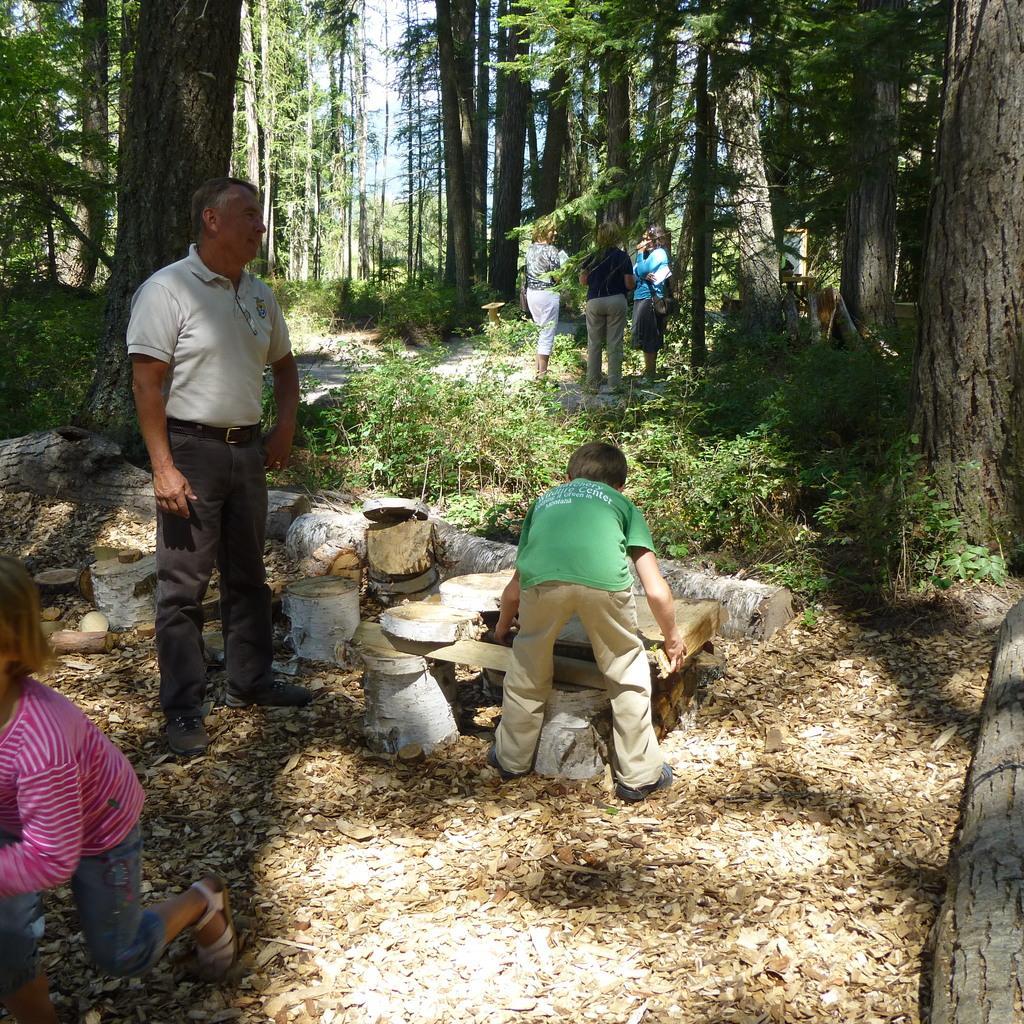Describe this image in one or two sentences. In the center of the image we can see the wood logs and a man is standing and a boy is holding a wood log. On the left side of the image we can see a girl is running. In the middle of the image we can see three persons are standing. In the background of the image we can see the trees, plants, ground and saw dust. At the top of the image we can see the sky. 